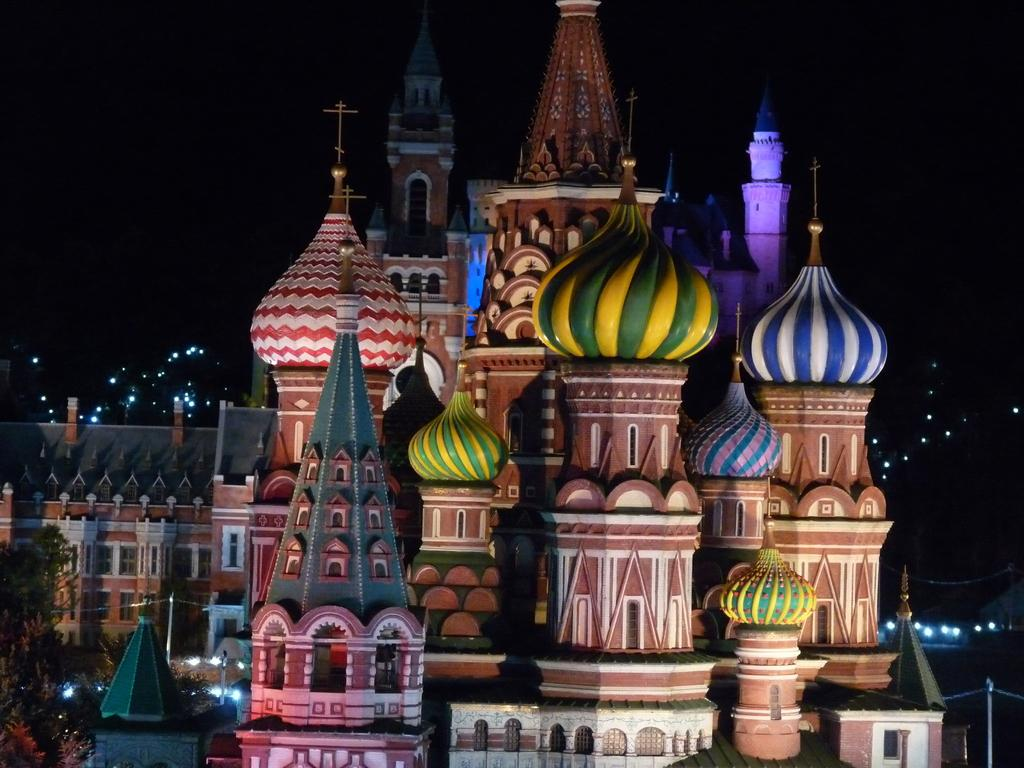What is the main structure in the center of the image? There is a castle in the center of the image. What can be seen in the background of the image? There are trees and at least one building in the background of the image. Are there any illuminated elements in the background? Yes, lights are visible in the background of the image. What type of wren can be seen flying around the castle in the image? There are no wrens present in the image; it features a castle and a background with trees and buildings. What religious symbol can be seen on the castle in the image? There is no religious symbol visible on the castle in the image. 